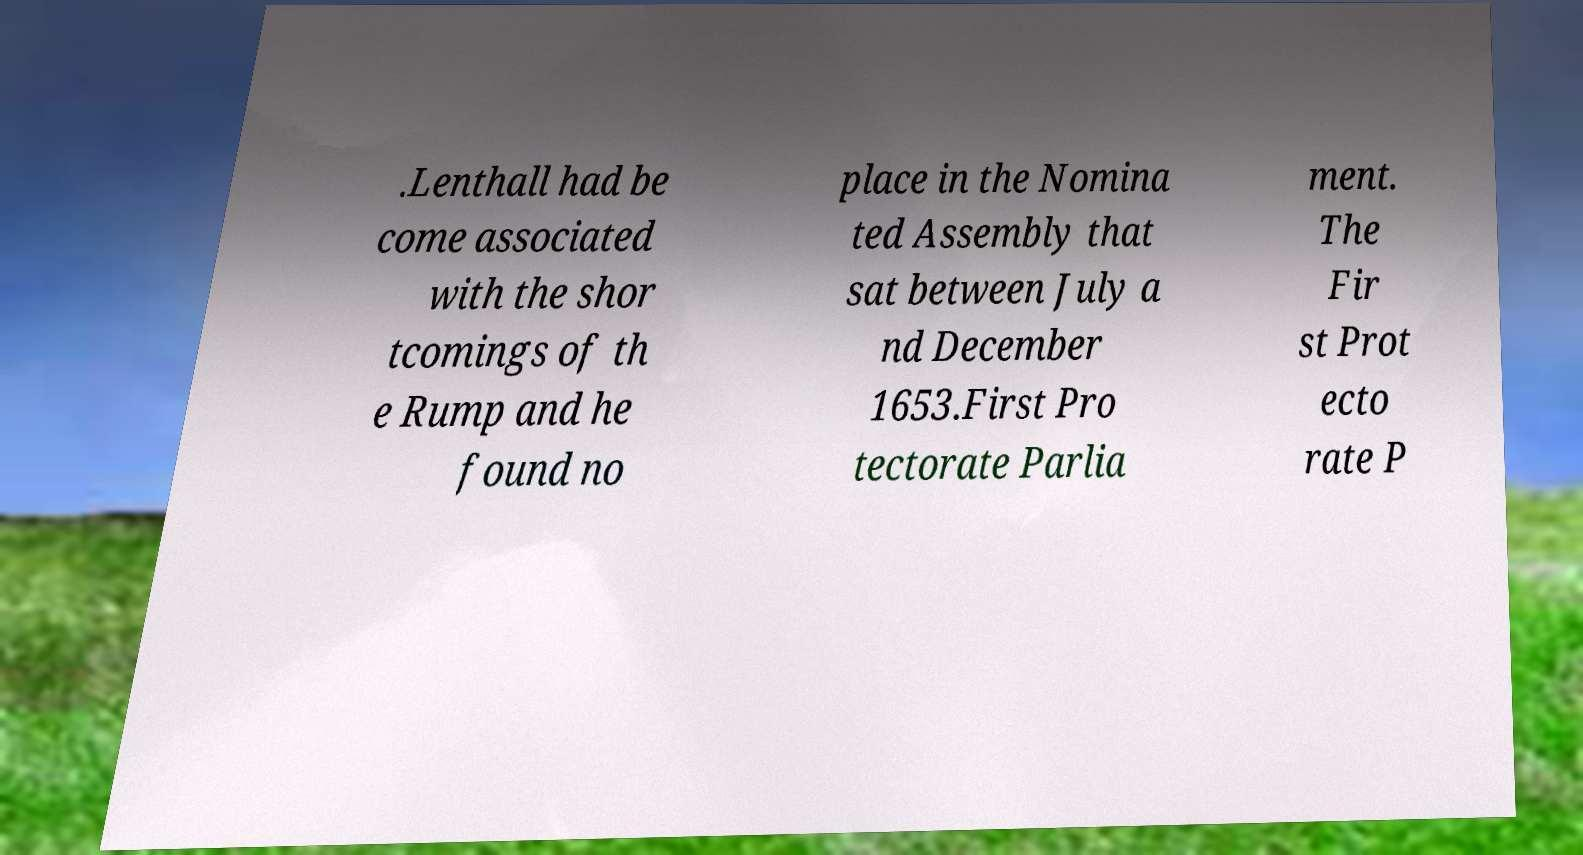What messages or text are displayed in this image? I need them in a readable, typed format. .Lenthall had be come associated with the shor tcomings of th e Rump and he found no place in the Nomina ted Assembly that sat between July a nd December 1653.First Pro tectorate Parlia ment. The Fir st Prot ecto rate P 